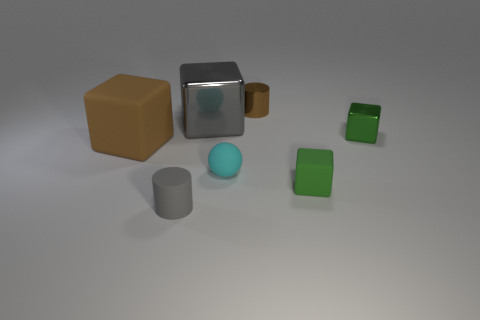Subtract 1 cubes. How many cubes are left? 3 Add 1 gray rubber balls. How many objects exist? 8 Subtract all blocks. How many objects are left? 3 Subtract 1 brown cubes. How many objects are left? 6 Subtract all small yellow spheres. Subtract all cyan balls. How many objects are left? 6 Add 1 big brown rubber objects. How many big brown rubber objects are left? 2 Add 4 large purple metal blocks. How many large purple metal blocks exist? 4 